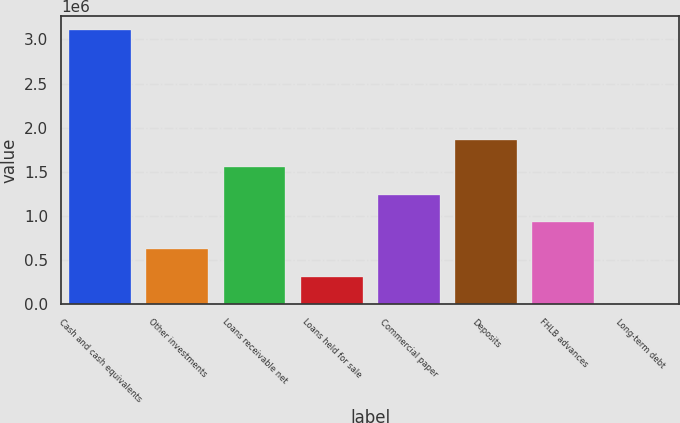Convert chart. <chart><loc_0><loc_0><loc_500><loc_500><bar_chart><fcel>Cash and cash equivalents<fcel>Other investments<fcel>Loans receivable net<fcel>Loans held for sale<fcel>Commercial paper<fcel>Deposits<fcel>FHLB advances<fcel>Long-term debt<nl><fcel>3.10445e+06<fcel>620892<fcel>1.55223e+06<fcel>310447<fcel>1.24178e+06<fcel>1.86267e+06<fcel>931337<fcel>2.38<nl></chart> 